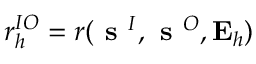<formula> <loc_0><loc_0><loc_500><loc_500>r _ { h } ^ { I O } = r ( s ^ { I } , s ^ { O } , E _ { h } )</formula> 